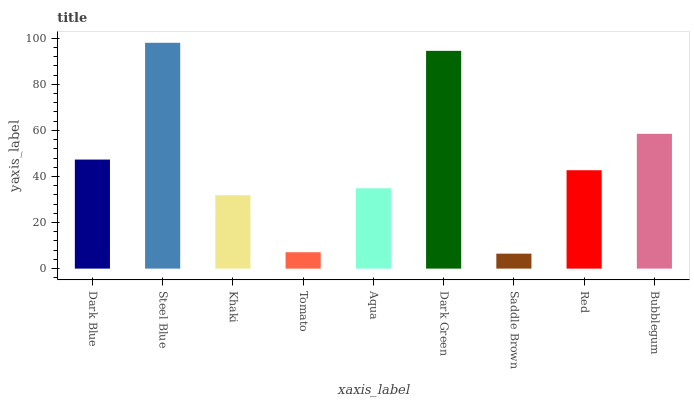Is Saddle Brown the minimum?
Answer yes or no. Yes. Is Steel Blue the maximum?
Answer yes or no. Yes. Is Khaki the minimum?
Answer yes or no. No. Is Khaki the maximum?
Answer yes or no. No. Is Steel Blue greater than Khaki?
Answer yes or no. Yes. Is Khaki less than Steel Blue?
Answer yes or no. Yes. Is Khaki greater than Steel Blue?
Answer yes or no. No. Is Steel Blue less than Khaki?
Answer yes or no. No. Is Red the high median?
Answer yes or no. Yes. Is Red the low median?
Answer yes or no. Yes. Is Tomato the high median?
Answer yes or no. No. Is Tomato the low median?
Answer yes or no. No. 